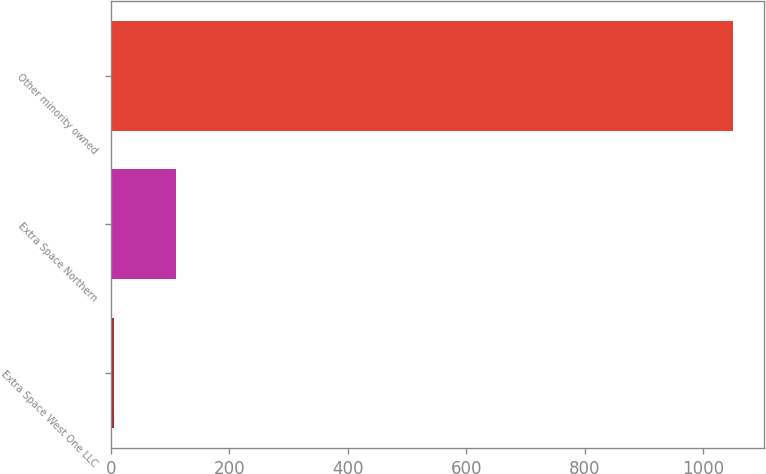<chart> <loc_0><loc_0><loc_500><loc_500><bar_chart><fcel>Extra Space West One LLC<fcel>Extra Space Northern<fcel>Other minority owned<nl><fcel>5<fcel>109.5<fcel>1050<nl></chart> 